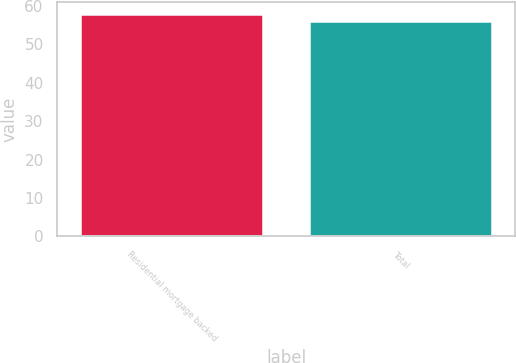Convert chart. <chart><loc_0><loc_0><loc_500><loc_500><bar_chart><fcel>Residential mortgage backed<fcel>Total<nl><fcel>58<fcel>56<nl></chart> 